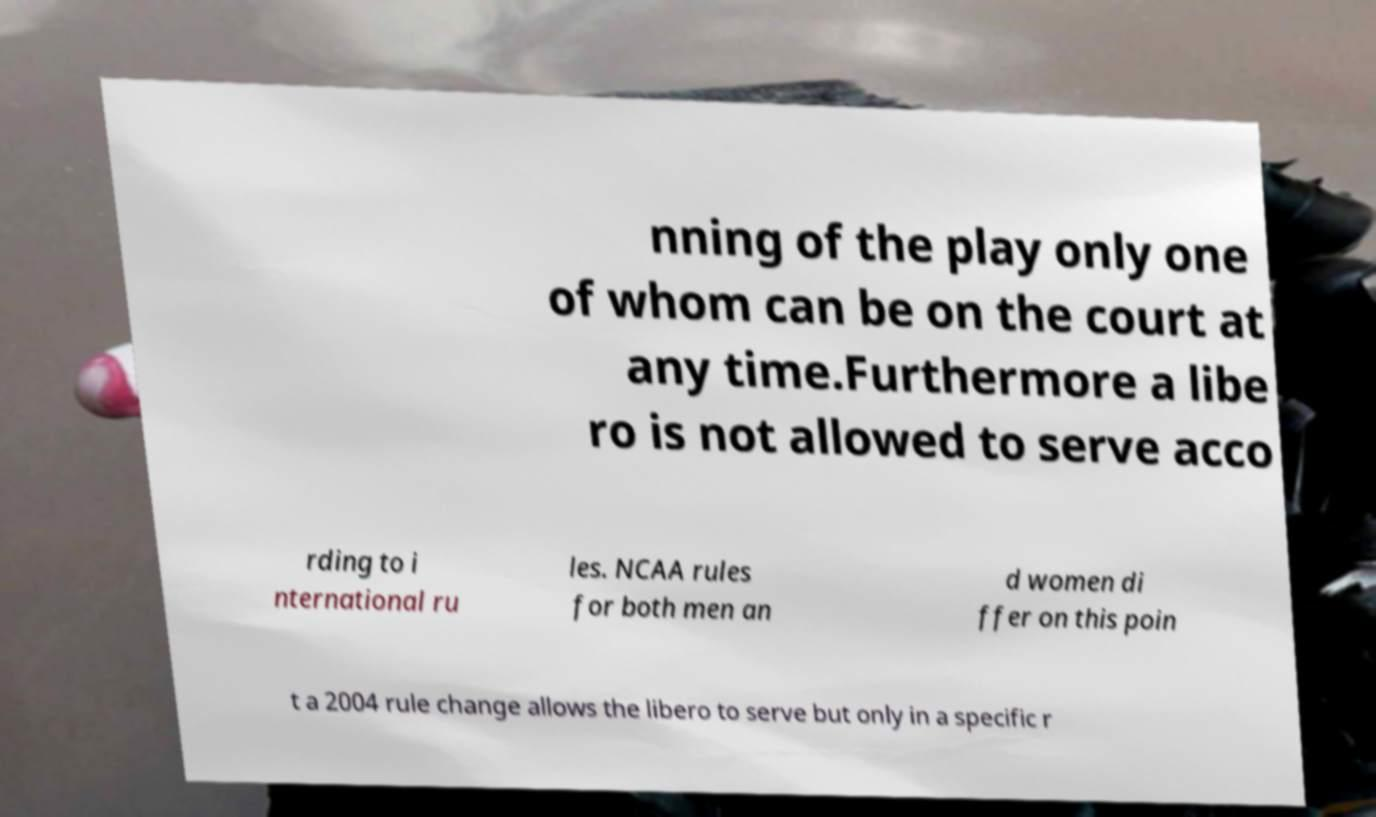Please identify and transcribe the text found in this image. nning of the play only one of whom can be on the court at any time.Furthermore a libe ro is not allowed to serve acco rding to i nternational ru les. NCAA rules for both men an d women di ffer on this poin t a 2004 rule change allows the libero to serve but only in a specific r 